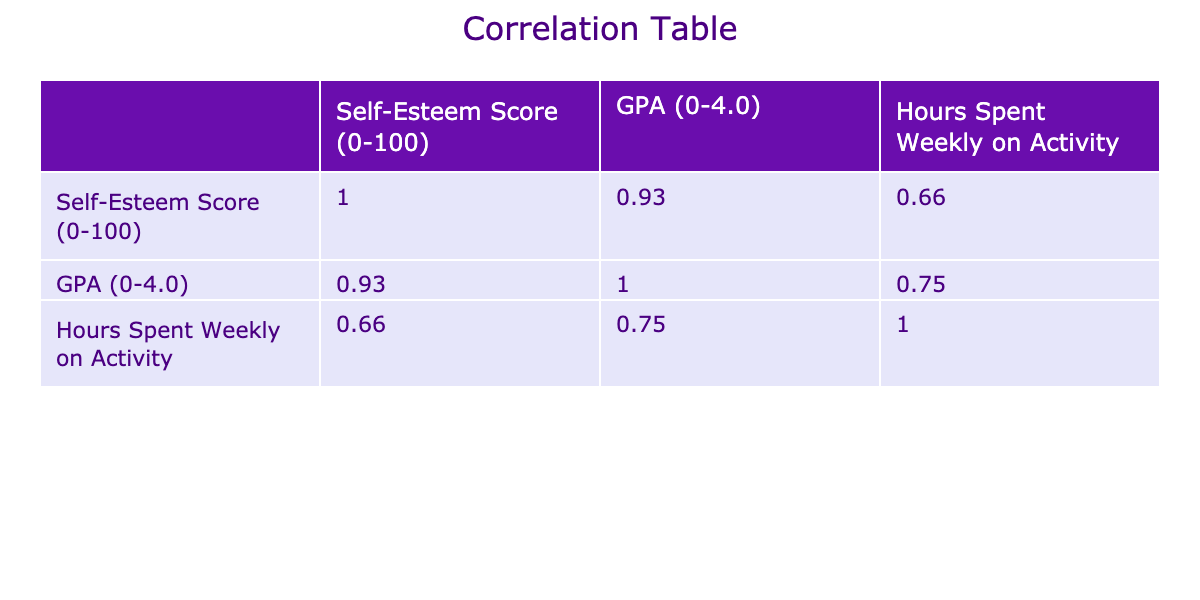What is the self-esteem score of Frank? The table shows Frank's self-esteem score is listed next to his name. According to the table, Frank has a self-esteem score of 88.
Answer: 88 What is the GPA of the participant who spends the most hours on extracurricular activities? Looking at the table, the participant who spends the most hours weekly is Frank with 7 hours. His GPA is 4.0.
Answer: 4.0 Is there a participant with a self-esteem score lower than 75? Checking the self-esteem scores in the table, the lowest score is 74 for Mona. Thus, it is true that there is at least one participant with a score lower than 75.
Answer: Yes What is the average self-esteem score of participants involved in sports-related extracurricular activities? The participants involved in sports are Alice (Swimming, 85), Isla (Track and Field, 92), and Nina (Soccer Team, 91). The average self-esteem score is calculated by (85 + 92 + 91) / 3 = 89.33.
Answer: 89.33 Which participant has the highest GPA and what extracurricular activity do they participate in? Looking through the table, Isla and Frank both have the highest GPA of 4.0. Isla participates in Track and Field, while Frank is part of the Robotics Team.
Answer: Isla (Track and Field) and Frank (Robotics Team) What is the correlation between hours spent weekly on activities and self-esteem scores? From the correlation table, we can see the correlation value between hours spent weekly on activities and self-esteem scores is determined, with values indicating a positive or negative relationship. For example, if the value is 0.6, it shows a moderate positive correlation. Specific values can be checked in the table once it's rendered.
Answer: (To be found in the correlation table) Are participants in the Drama Club more likely to have a self-esteem score above 80? The self-esteem score for Bob from the Drama Club is 78, which is below 80. Thus, it indicates that participants from the Drama Club are not more likely to score above 80.
Answer: No What is the median GPA of all participants in the correlation table? To find the median GPA, we first list the GPA scores: 3.2, 3.3, 3.4, 3.5, 3.5, 3.6, 3.6, 3.7, 3.8, 3.8, 3.9, 3.9, 4.0, 4.0. Arranging them gives us 3.2 to 4.0 and the median, which is the average of the 7th and 8th scores, is (3.6 + 3.7) / 2 = 3.65.
Answer: 3.65 